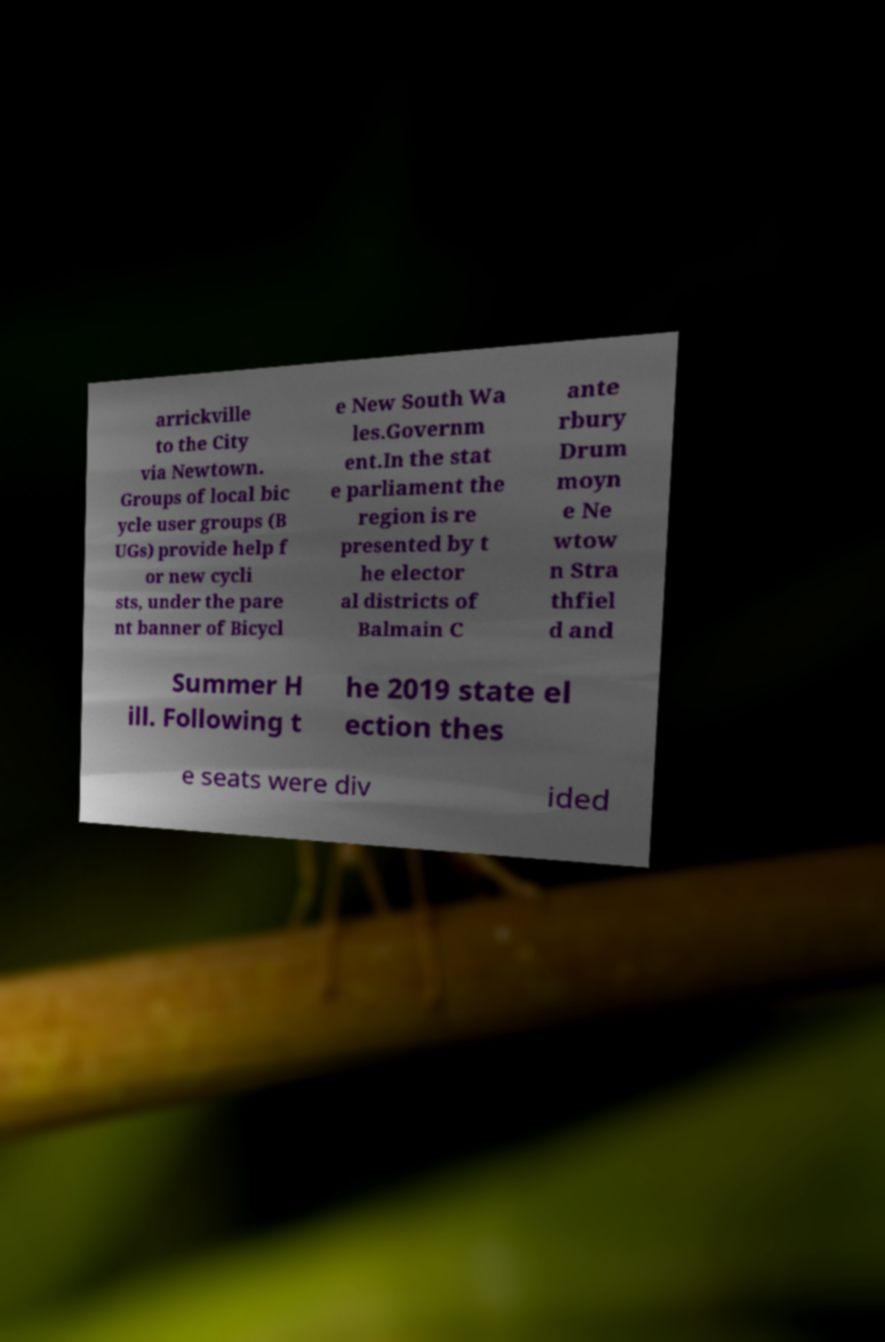I need the written content from this picture converted into text. Can you do that? arrickville to the City via Newtown. Groups of local bic ycle user groups (B UGs) provide help f or new cycli sts, under the pare nt banner of Bicycl e New South Wa les.Governm ent.In the stat e parliament the region is re presented by t he elector al districts of Balmain C ante rbury Drum moyn e Ne wtow n Stra thfiel d and Summer H ill. Following t he 2019 state el ection thes e seats were div ided 